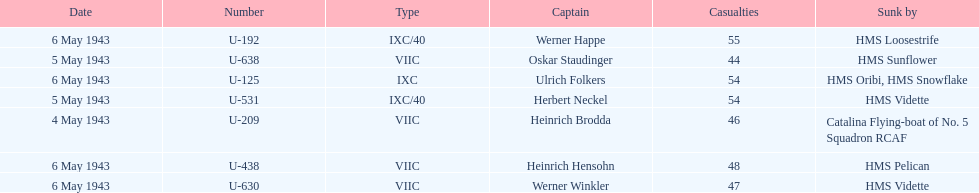How many more casualties occurred on may 6 compared to may 4? 158. 